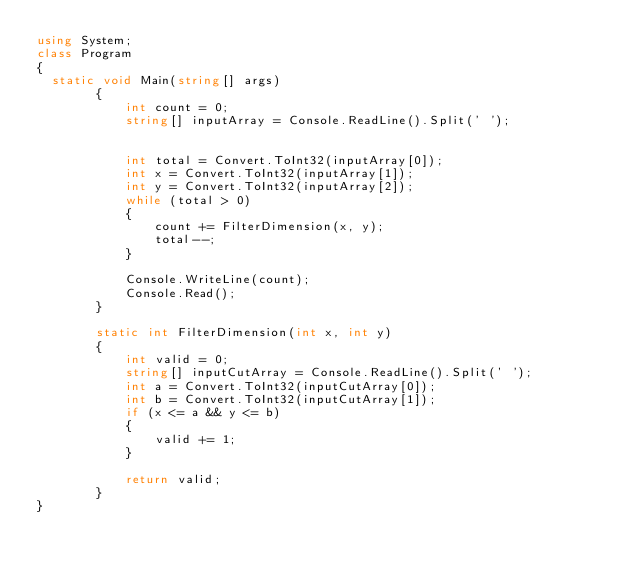<code> <loc_0><loc_0><loc_500><loc_500><_C#_>using System;
class Program
{
	static void Main(string[] args)
        {
            int count = 0;
            string[] inputArray = Console.ReadLine().Split(' ');
            

            int total = Convert.ToInt32(inputArray[0]);
            int x = Convert.ToInt32(inputArray[1]);
            int y = Convert.ToInt32(inputArray[2]);
            while (total > 0)
            {
                count += FilterDimension(x, y);
                total--;
            }
            
            Console.WriteLine(count);
            Console.Read();
        }

        static int FilterDimension(int x, int y)
        {
            int valid = 0;
            string[] inputCutArray = Console.ReadLine().Split(' ');
            int a = Convert.ToInt32(inputCutArray[0]);
            int b = Convert.ToInt32(inputCutArray[1]);
            if (x <= a && y <= b)
            {
                valid += 1;
            }

            return valid;
        }
}</code> 